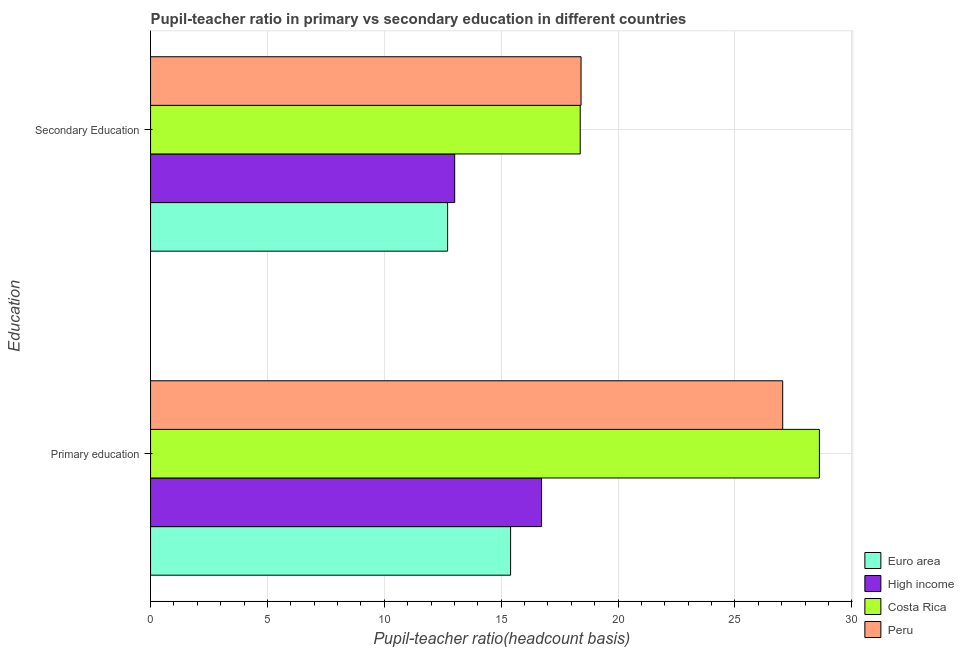How many groups of bars are there?
Make the answer very short. 2. Are the number of bars on each tick of the Y-axis equal?
Make the answer very short. Yes. What is the label of the 2nd group of bars from the top?
Your answer should be very brief. Primary education. What is the pupil-teacher ratio in primary education in Euro area?
Make the answer very short. 15.4. Across all countries, what is the maximum pupil-teacher ratio in primary education?
Your answer should be compact. 28.61. Across all countries, what is the minimum pupil-teacher ratio in primary education?
Ensure brevity in your answer.  15.4. In which country was the pupil-teacher ratio in primary education maximum?
Offer a very short reply. Costa Rica. In which country was the pupil teacher ratio on secondary education minimum?
Ensure brevity in your answer.  Euro area. What is the total pupil-teacher ratio in primary education in the graph?
Keep it short and to the point. 87.78. What is the difference between the pupil-teacher ratio in primary education in Costa Rica and that in Peru?
Offer a very short reply. 1.57. What is the difference between the pupil teacher ratio on secondary education in High income and the pupil-teacher ratio in primary education in Costa Rica?
Give a very brief answer. -15.6. What is the average pupil-teacher ratio in primary education per country?
Your answer should be very brief. 21.95. What is the difference between the pupil teacher ratio on secondary education and pupil-teacher ratio in primary education in High income?
Offer a terse response. -3.72. In how many countries, is the pupil teacher ratio on secondary education greater than 26 ?
Keep it short and to the point. 0. What is the ratio of the pupil teacher ratio on secondary education in Costa Rica to that in Peru?
Your answer should be very brief. 1. How many bars are there?
Provide a short and direct response. 8. Are all the bars in the graph horizontal?
Offer a terse response. Yes. How many countries are there in the graph?
Offer a terse response. 4. What is the difference between two consecutive major ticks on the X-axis?
Your answer should be very brief. 5. Are the values on the major ticks of X-axis written in scientific E-notation?
Your answer should be compact. No. Does the graph contain any zero values?
Your answer should be very brief. No. Where does the legend appear in the graph?
Offer a terse response. Bottom right. How many legend labels are there?
Offer a very short reply. 4. What is the title of the graph?
Provide a short and direct response. Pupil-teacher ratio in primary vs secondary education in different countries. What is the label or title of the X-axis?
Give a very brief answer. Pupil-teacher ratio(headcount basis). What is the label or title of the Y-axis?
Make the answer very short. Education. What is the Pupil-teacher ratio(headcount basis) in Euro area in Primary education?
Your answer should be very brief. 15.4. What is the Pupil-teacher ratio(headcount basis) of High income in Primary education?
Keep it short and to the point. 16.73. What is the Pupil-teacher ratio(headcount basis) of Costa Rica in Primary education?
Give a very brief answer. 28.61. What is the Pupil-teacher ratio(headcount basis) in Peru in Primary education?
Provide a short and direct response. 27.04. What is the Pupil-teacher ratio(headcount basis) of Euro area in Secondary Education?
Make the answer very short. 12.71. What is the Pupil-teacher ratio(headcount basis) of High income in Secondary Education?
Provide a succinct answer. 13.01. What is the Pupil-teacher ratio(headcount basis) in Costa Rica in Secondary Education?
Your response must be concise. 18.38. What is the Pupil-teacher ratio(headcount basis) in Peru in Secondary Education?
Your answer should be compact. 18.42. Across all Education, what is the maximum Pupil-teacher ratio(headcount basis) of Euro area?
Make the answer very short. 15.4. Across all Education, what is the maximum Pupil-teacher ratio(headcount basis) of High income?
Your response must be concise. 16.73. Across all Education, what is the maximum Pupil-teacher ratio(headcount basis) of Costa Rica?
Offer a terse response. 28.61. Across all Education, what is the maximum Pupil-teacher ratio(headcount basis) in Peru?
Give a very brief answer. 27.04. Across all Education, what is the minimum Pupil-teacher ratio(headcount basis) in Euro area?
Your response must be concise. 12.71. Across all Education, what is the minimum Pupil-teacher ratio(headcount basis) in High income?
Offer a terse response. 13.01. Across all Education, what is the minimum Pupil-teacher ratio(headcount basis) in Costa Rica?
Ensure brevity in your answer.  18.38. Across all Education, what is the minimum Pupil-teacher ratio(headcount basis) in Peru?
Provide a succinct answer. 18.42. What is the total Pupil-teacher ratio(headcount basis) in Euro area in the graph?
Keep it short and to the point. 28.11. What is the total Pupil-teacher ratio(headcount basis) of High income in the graph?
Your response must be concise. 29.74. What is the total Pupil-teacher ratio(headcount basis) in Costa Rica in the graph?
Provide a succinct answer. 46.99. What is the total Pupil-teacher ratio(headcount basis) in Peru in the graph?
Provide a short and direct response. 45.46. What is the difference between the Pupil-teacher ratio(headcount basis) of Euro area in Primary education and that in Secondary Education?
Your answer should be very brief. 2.69. What is the difference between the Pupil-teacher ratio(headcount basis) in High income in Primary education and that in Secondary Education?
Give a very brief answer. 3.72. What is the difference between the Pupil-teacher ratio(headcount basis) in Costa Rica in Primary education and that in Secondary Education?
Ensure brevity in your answer.  10.23. What is the difference between the Pupil-teacher ratio(headcount basis) in Peru in Primary education and that in Secondary Education?
Make the answer very short. 8.63. What is the difference between the Pupil-teacher ratio(headcount basis) in Euro area in Primary education and the Pupil-teacher ratio(headcount basis) in High income in Secondary Education?
Provide a short and direct response. 2.39. What is the difference between the Pupil-teacher ratio(headcount basis) of Euro area in Primary education and the Pupil-teacher ratio(headcount basis) of Costa Rica in Secondary Education?
Offer a very short reply. -2.98. What is the difference between the Pupil-teacher ratio(headcount basis) in Euro area in Primary education and the Pupil-teacher ratio(headcount basis) in Peru in Secondary Education?
Your answer should be very brief. -3.01. What is the difference between the Pupil-teacher ratio(headcount basis) in High income in Primary education and the Pupil-teacher ratio(headcount basis) in Costa Rica in Secondary Education?
Provide a succinct answer. -1.65. What is the difference between the Pupil-teacher ratio(headcount basis) in High income in Primary education and the Pupil-teacher ratio(headcount basis) in Peru in Secondary Education?
Provide a succinct answer. -1.69. What is the difference between the Pupil-teacher ratio(headcount basis) of Costa Rica in Primary education and the Pupil-teacher ratio(headcount basis) of Peru in Secondary Education?
Offer a very short reply. 10.2. What is the average Pupil-teacher ratio(headcount basis) in Euro area per Education?
Your response must be concise. 14.05. What is the average Pupil-teacher ratio(headcount basis) in High income per Education?
Offer a very short reply. 14.87. What is the average Pupil-teacher ratio(headcount basis) in Costa Rica per Education?
Give a very brief answer. 23.5. What is the average Pupil-teacher ratio(headcount basis) of Peru per Education?
Offer a terse response. 22.73. What is the difference between the Pupil-teacher ratio(headcount basis) of Euro area and Pupil-teacher ratio(headcount basis) of High income in Primary education?
Offer a very short reply. -1.32. What is the difference between the Pupil-teacher ratio(headcount basis) in Euro area and Pupil-teacher ratio(headcount basis) in Costa Rica in Primary education?
Make the answer very short. -13.21. What is the difference between the Pupil-teacher ratio(headcount basis) in Euro area and Pupil-teacher ratio(headcount basis) in Peru in Primary education?
Give a very brief answer. -11.64. What is the difference between the Pupil-teacher ratio(headcount basis) of High income and Pupil-teacher ratio(headcount basis) of Costa Rica in Primary education?
Your answer should be very brief. -11.89. What is the difference between the Pupil-teacher ratio(headcount basis) of High income and Pupil-teacher ratio(headcount basis) of Peru in Primary education?
Your response must be concise. -10.32. What is the difference between the Pupil-teacher ratio(headcount basis) in Costa Rica and Pupil-teacher ratio(headcount basis) in Peru in Primary education?
Offer a very short reply. 1.57. What is the difference between the Pupil-teacher ratio(headcount basis) of Euro area and Pupil-teacher ratio(headcount basis) of High income in Secondary Education?
Your answer should be compact. -0.3. What is the difference between the Pupil-teacher ratio(headcount basis) of Euro area and Pupil-teacher ratio(headcount basis) of Costa Rica in Secondary Education?
Offer a very short reply. -5.67. What is the difference between the Pupil-teacher ratio(headcount basis) in Euro area and Pupil-teacher ratio(headcount basis) in Peru in Secondary Education?
Your answer should be compact. -5.71. What is the difference between the Pupil-teacher ratio(headcount basis) of High income and Pupil-teacher ratio(headcount basis) of Costa Rica in Secondary Education?
Offer a terse response. -5.37. What is the difference between the Pupil-teacher ratio(headcount basis) of High income and Pupil-teacher ratio(headcount basis) of Peru in Secondary Education?
Provide a short and direct response. -5.41. What is the difference between the Pupil-teacher ratio(headcount basis) in Costa Rica and Pupil-teacher ratio(headcount basis) in Peru in Secondary Education?
Make the answer very short. -0.04. What is the ratio of the Pupil-teacher ratio(headcount basis) of Euro area in Primary education to that in Secondary Education?
Your answer should be very brief. 1.21. What is the ratio of the Pupil-teacher ratio(headcount basis) in High income in Primary education to that in Secondary Education?
Provide a short and direct response. 1.29. What is the ratio of the Pupil-teacher ratio(headcount basis) of Costa Rica in Primary education to that in Secondary Education?
Provide a short and direct response. 1.56. What is the ratio of the Pupil-teacher ratio(headcount basis) in Peru in Primary education to that in Secondary Education?
Provide a short and direct response. 1.47. What is the difference between the highest and the second highest Pupil-teacher ratio(headcount basis) of Euro area?
Give a very brief answer. 2.69. What is the difference between the highest and the second highest Pupil-teacher ratio(headcount basis) in High income?
Your answer should be very brief. 3.72. What is the difference between the highest and the second highest Pupil-teacher ratio(headcount basis) of Costa Rica?
Your response must be concise. 10.23. What is the difference between the highest and the second highest Pupil-teacher ratio(headcount basis) of Peru?
Keep it short and to the point. 8.63. What is the difference between the highest and the lowest Pupil-teacher ratio(headcount basis) of Euro area?
Your response must be concise. 2.69. What is the difference between the highest and the lowest Pupil-teacher ratio(headcount basis) of High income?
Give a very brief answer. 3.72. What is the difference between the highest and the lowest Pupil-teacher ratio(headcount basis) of Costa Rica?
Offer a very short reply. 10.23. What is the difference between the highest and the lowest Pupil-teacher ratio(headcount basis) of Peru?
Your answer should be compact. 8.63. 